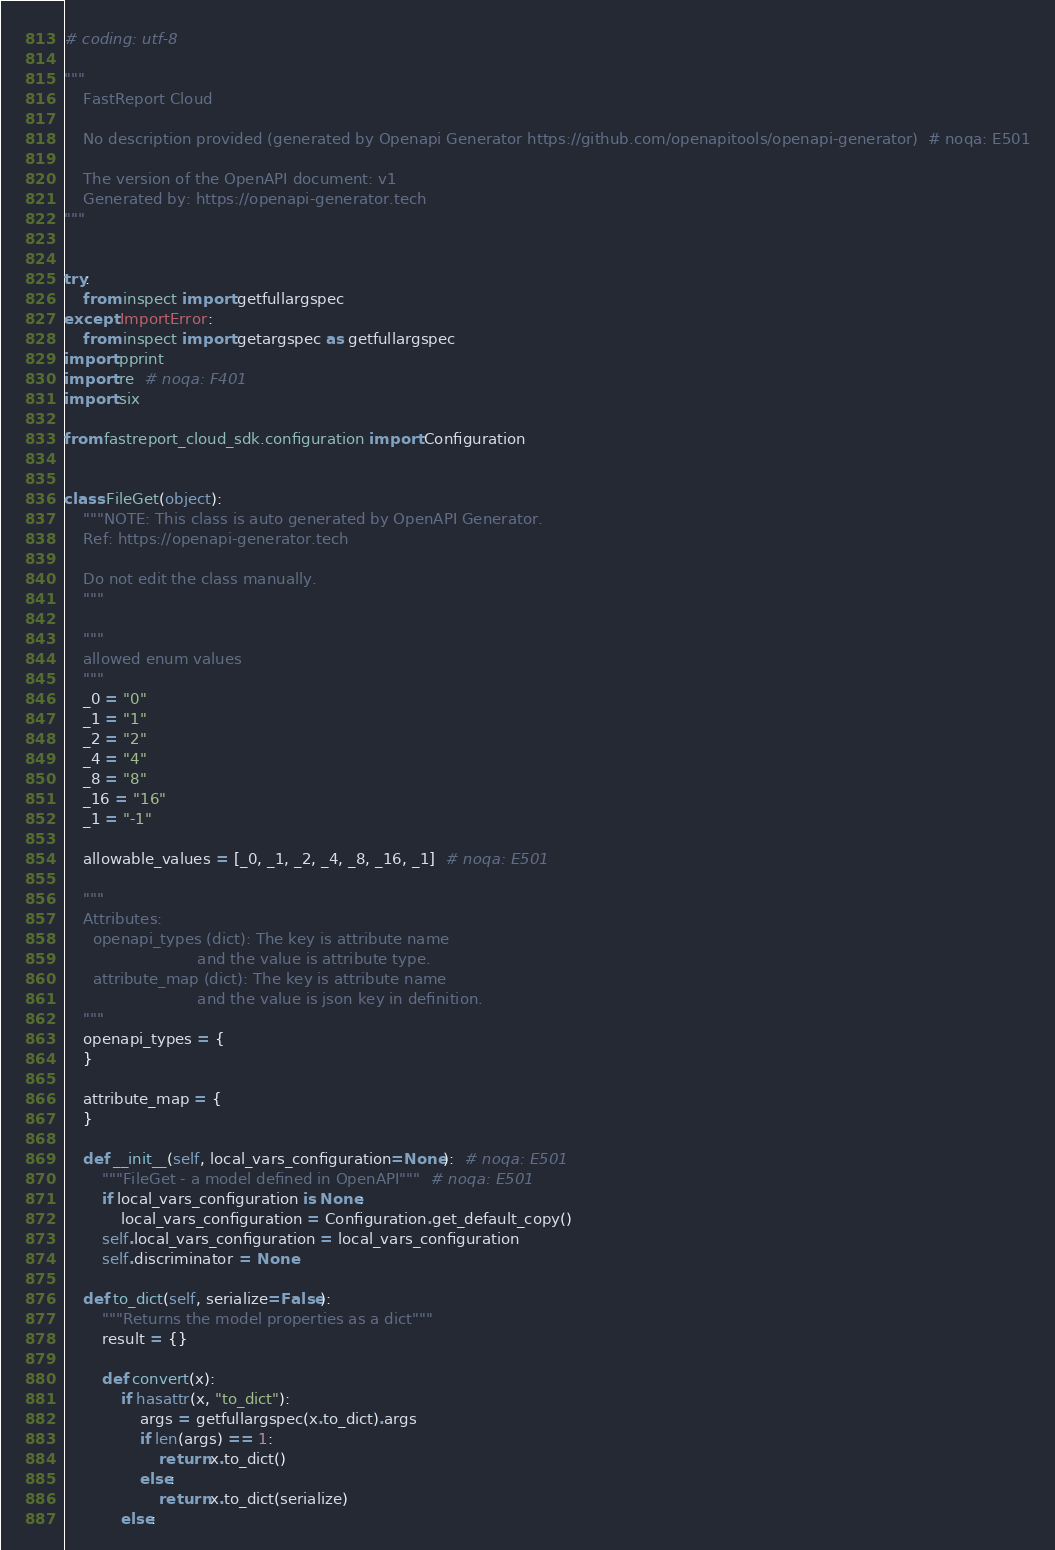<code> <loc_0><loc_0><loc_500><loc_500><_Python_># coding: utf-8

"""
    FastReport Cloud

    No description provided (generated by Openapi Generator https://github.com/openapitools/openapi-generator)  # noqa: E501

    The version of the OpenAPI document: v1
    Generated by: https://openapi-generator.tech
"""


try:
    from inspect import getfullargspec
except ImportError:
    from inspect import getargspec as getfullargspec
import pprint
import re  # noqa: F401
import six

from fastreport_cloud_sdk.configuration import Configuration


class FileGet(object):
    """NOTE: This class is auto generated by OpenAPI Generator.
    Ref: https://openapi-generator.tech

    Do not edit the class manually.
    """

    """
    allowed enum values
    """
    _0 = "0"
    _1 = "1"
    _2 = "2"
    _4 = "4"
    _8 = "8"
    _16 = "16"
    _1 = "-1"

    allowable_values = [_0, _1, _2, _4, _8, _16, _1]  # noqa: E501

    """
    Attributes:
      openapi_types (dict): The key is attribute name
                            and the value is attribute type.
      attribute_map (dict): The key is attribute name
                            and the value is json key in definition.
    """
    openapi_types = {
    }

    attribute_map = {
    }

    def __init__(self, local_vars_configuration=None):  # noqa: E501
        """FileGet - a model defined in OpenAPI"""  # noqa: E501
        if local_vars_configuration is None:
            local_vars_configuration = Configuration.get_default_copy()
        self.local_vars_configuration = local_vars_configuration
        self.discriminator = None

    def to_dict(self, serialize=False):
        """Returns the model properties as a dict"""
        result = {}

        def convert(x):
            if hasattr(x, "to_dict"):
                args = getfullargspec(x.to_dict).args
                if len(args) == 1:
                    return x.to_dict()
                else:
                    return x.to_dict(serialize)
            else:</code> 